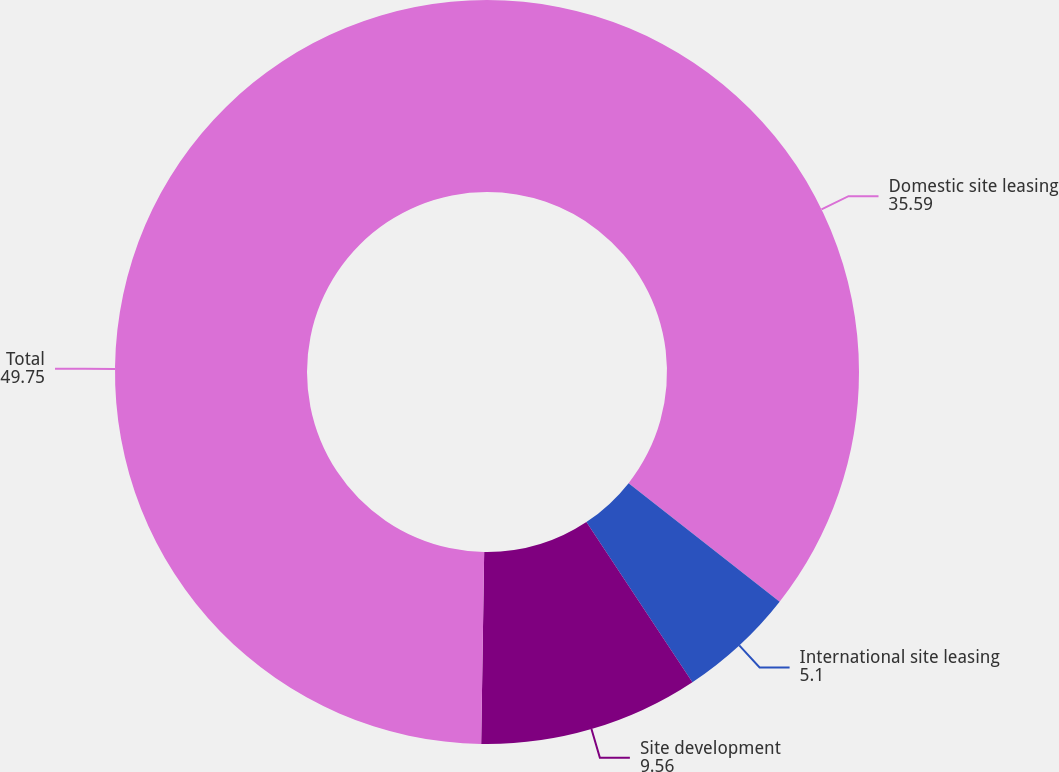Convert chart to OTSL. <chart><loc_0><loc_0><loc_500><loc_500><pie_chart><fcel>Domestic site leasing<fcel>International site leasing<fcel>Site development<fcel>Total<nl><fcel>35.59%<fcel>5.1%<fcel>9.56%<fcel>49.75%<nl></chart> 